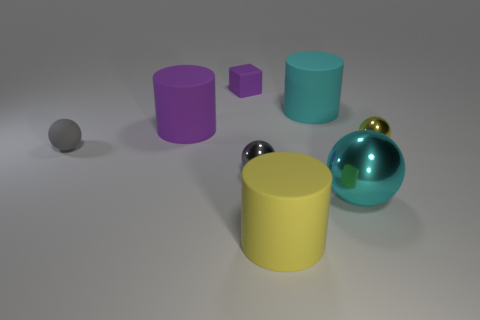Add 1 yellow metal balls. How many objects exist? 9 Subtract all cubes. How many objects are left? 7 Subtract all large metal things. Subtract all gray objects. How many objects are left? 5 Add 6 small yellow metal things. How many small yellow metal things are left? 7 Add 6 gray metallic balls. How many gray metallic balls exist? 7 Subtract 0 yellow cubes. How many objects are left? 8 